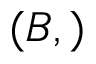<formula> <loc_0><loc_0><loc_500><loc_500>( B , )</formula> 